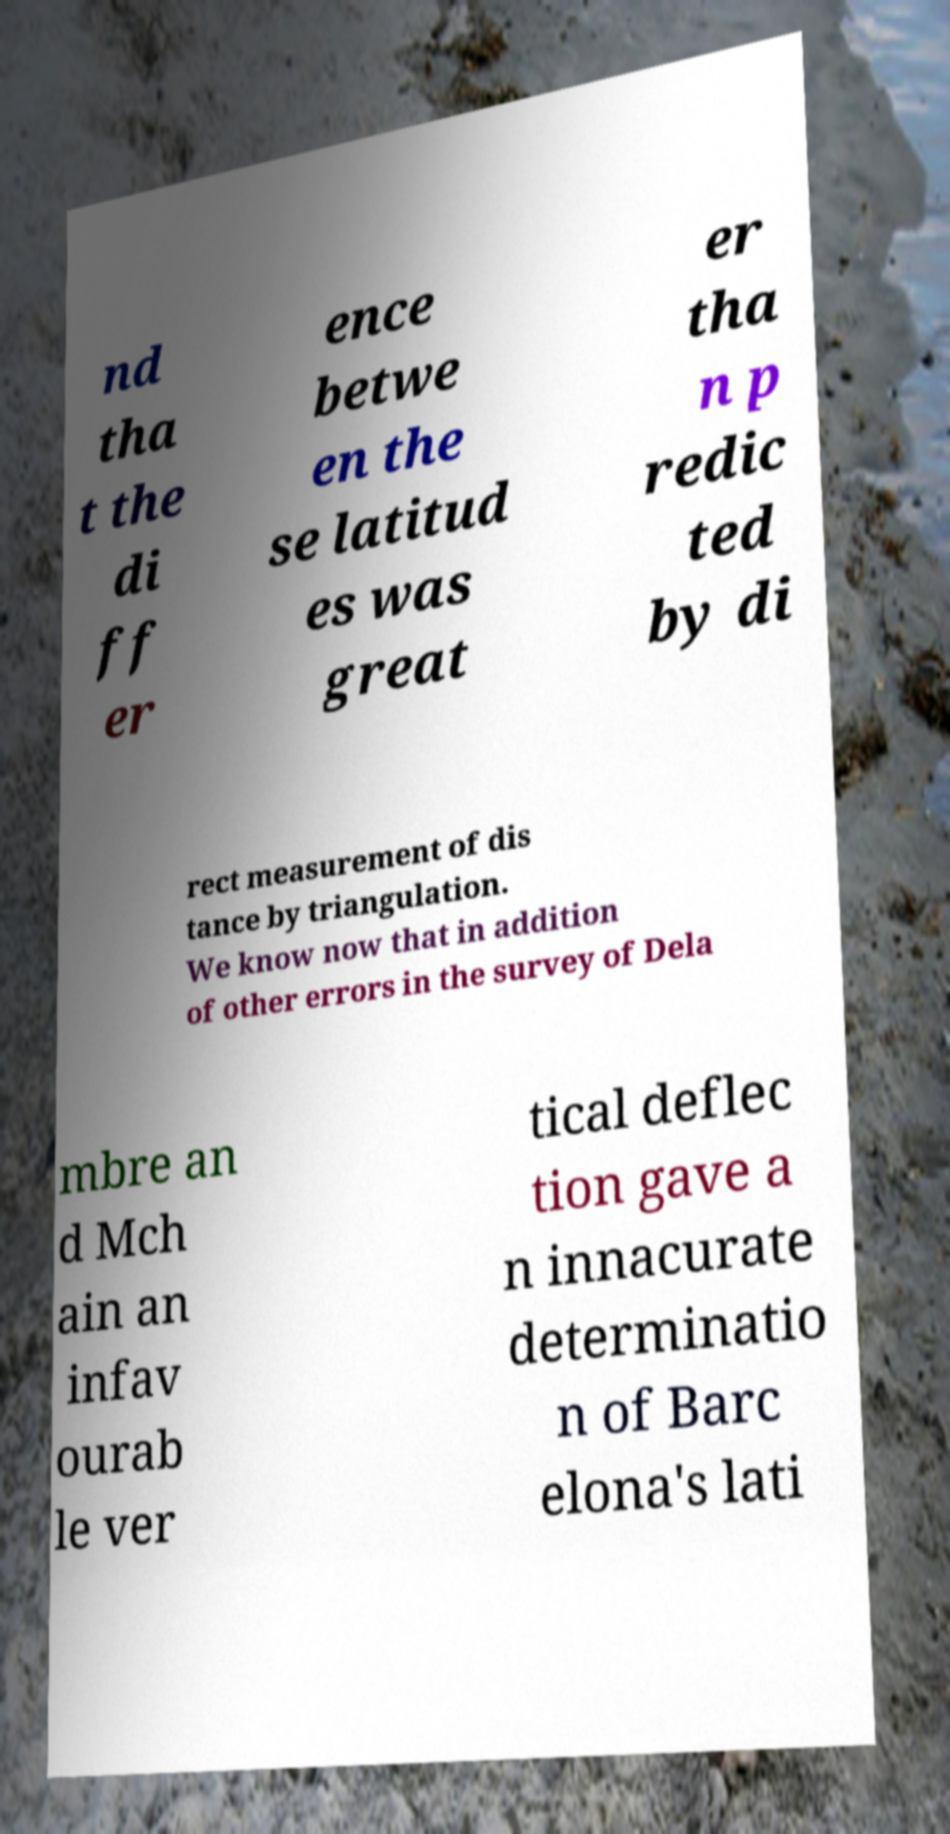Could you assist in decoding the text presented in this image and type it out clearly? nd tha t the di ff er ence betwe en the se latitud es was great er tha n p redic ted by di rect measurement of dis tance by triangulation. We know now that in addition of other errors in the survey of Dela mbre an d Mch ain an infav ourab le ver tical deflec tion gave a n innacurate determinatio n of Barc elona's lati 